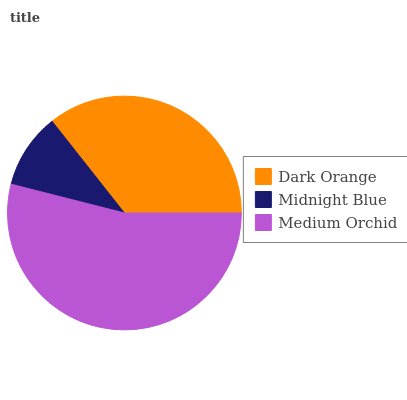Is Midnight Blue the minimum?
Answer yes or no. Yes. Is Medium Orchid the maximum?
Answer yes or no. Yes. Is Medium Orchid the minimum?
Answer yes or no. No. Is Midnight Blue the maximum?
Answer yes or no. No. Is Medium Orchid greater than Midnight Blue?
Answer yes or no. Yes. Is Midnight Blue less than Medium Orchid?
Answer yes or no. Yes. Is Midnight Blue greater than Medium Orchid?
Answer yes or no. No. Is Medium Orchid less than Midnight Blue?
Answer yes or no. No. Is Dark Orange the high median?
Answer yes or no. Yes. Is Dark Orange the low median?
Answer yes or no. Yes. Is Midnight Blue the high median?
Answer yes or no. No. Is Medium Orchid the low median?
Answer yes or no. No. 